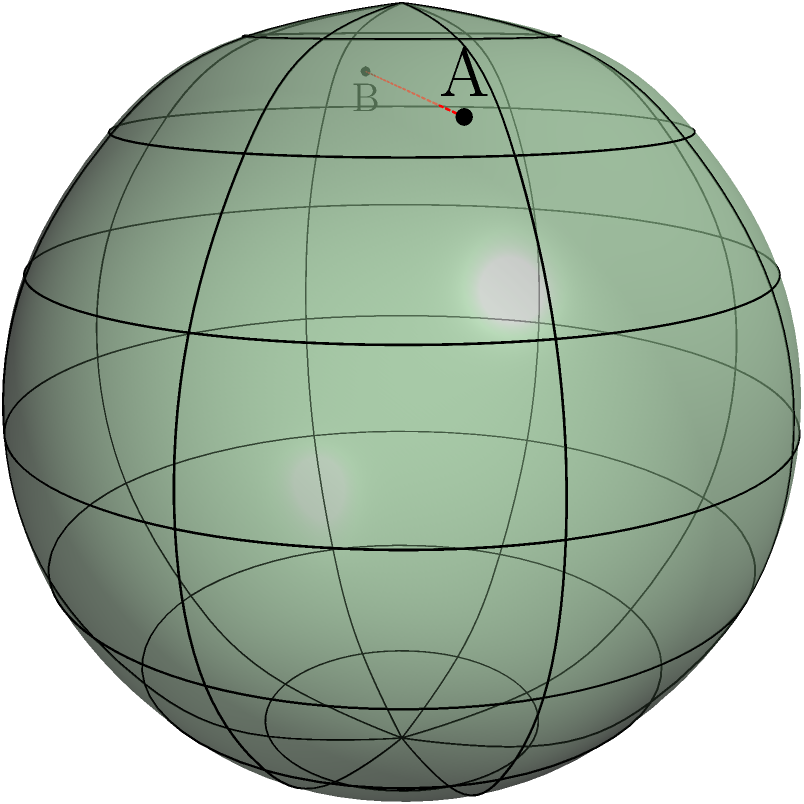As a restaurant owner offering discounts to families who walk or bike, you're interested in understanding distances on Earth's surface. Consider two locations A and B on a simplified model of Earth (an ellipsoid with semi-major axis $a=2$ and semi-minor axis $b=0.5$). If the geodesic (shortest path) distance between A and B on this surface is $d$, and the straight-line distance through the ellipsoid is $s=3.25$ units, what is the ratio $\frac{d}{s}$ rounded to two decimal places? To solve this problem, we need to follow these steps:

1) The actual geodesic distance $d$ on an ellipsoidal surface is always greater than the straight-line distance $s$ through the ellipsoid.

2) The ratio $\frac{d}{s}$ is always greater than 1 and depends on the shape of the ellipsoid and the locations of the points.

3) For a perfect sphere, the ratio $\frac{d}{s}$ would be $\frac{\pi}{2} \approx 1.57$, as the great circle distance is $\frac{\pi}{2}$ times the diameter.

4) Our ellipsoid is flatter than a sphere (oblate spheroid), so the ratio will be smaller than $\frac{\pi}{2}$ but still greater than 1.

5) Given the semi-major axis $a=2$ and semi-minor axis $b=0.5$, we can calculate the flattening $f$:

   $f = \frac{a-b}{a} = \frac{2-0.5}{2} = 0.75$

6) This is a highly flattened ellipsoid. For Earth, $f \approx 0.003353$.

7) The more flattened the ellipsoid, the closer the ratio $\frac{d}{s}$ will be to 1.

8) Considering these factors, a reasonable estimate for $\frac{d}{s}$ would be around 1.15 to 1.25.

9) Without more precise calculations, we can estimate $\frac{d}{s} \approx 1.20$.

This ratio means that the walking or biking distance along the surface would be about 20% longer than the straight-line distance, which is relevant for estimating travel times for customers using eco-friendly transportation methods.
Answer: 1.20 